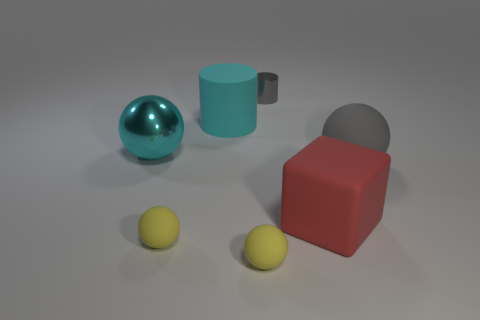Are there any other things that are the same shape as the red rubber object?
Provide a succinct answer. No. How many large matte balls are in front of the gray thing that is on the left side of the matte sphere that is behind the large red rubber block?
Your answer should be very brief. 1. What number of rubber spheres are left of the gray metal cylinder and behind the large red matte thing?
Your answer should be very brief. 0. Are there any other things that are the same color as the large metal sphere?
Your response must be concise. Yes. How many rubber things are either small green blocks or tiny gray cylinders?
Your response must be concise. 0. What material is the big sphere that is left of the ball that is on the right side of the gray object that is to the left of the large matte ball?
Your answer should be compact. Metal. The ball behind the big matte thing right of the red thing is made of what material?
Your answer should be very brief. Metal. There is a block that is in front of the cyan matte object; does it have the same size as the cylinder behind the big cyan cylinder?
Your answer should be very brief. No. Are there any other things that have the same material as the red block?
Your response must be concise. Yes. What number of large objects are cyan matte cylinders or gray balls?
Provide a short and direct response. 2. 